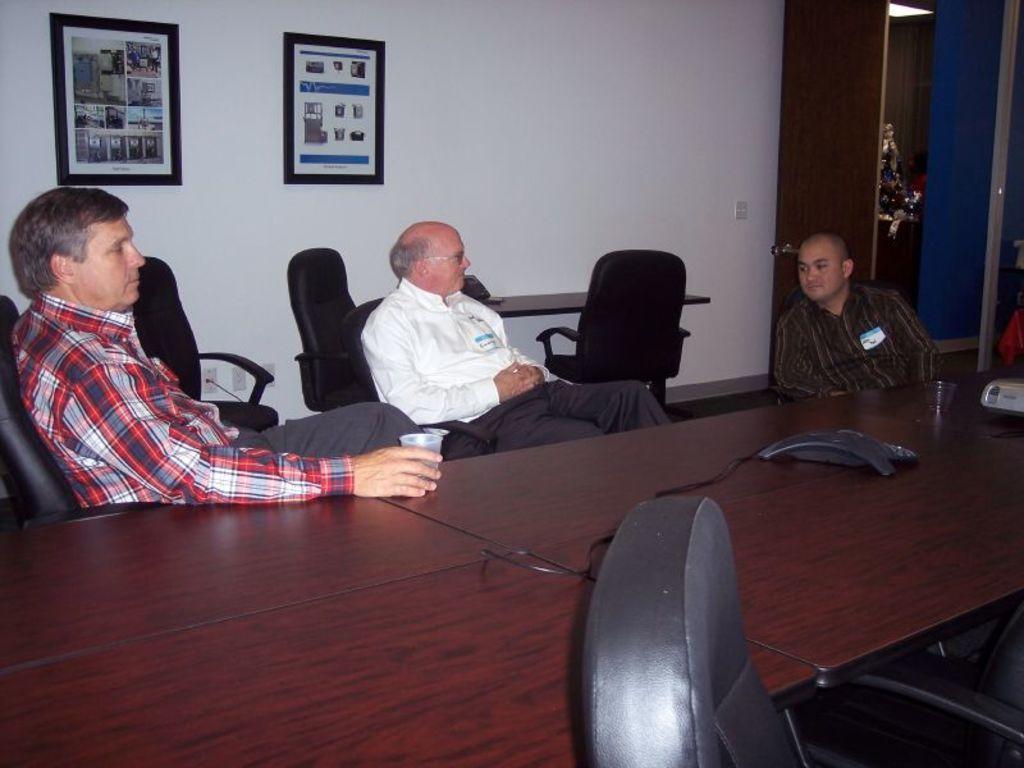Please provide a concise description of this image. In the image we can see there are three people who are sitting on chair and in front of them there is a table on which there is a glass and at the back on the wall there are two photo frames. 